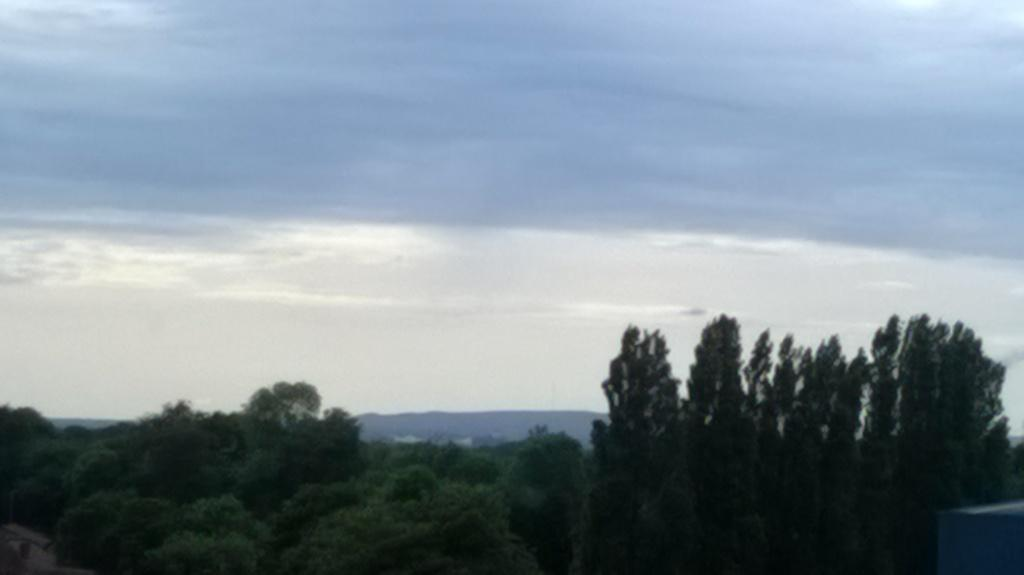What can be seen in the background of the image? There is a sky in the image. What type of vegetation is present in the image? There are trees in the image. What geographical feature is visible in the image? There are mountains in the image. How many loaves of bread are visible in the image? There is no bread present in the image. What type of cake is being served in the image? There is no cake present in the image. 